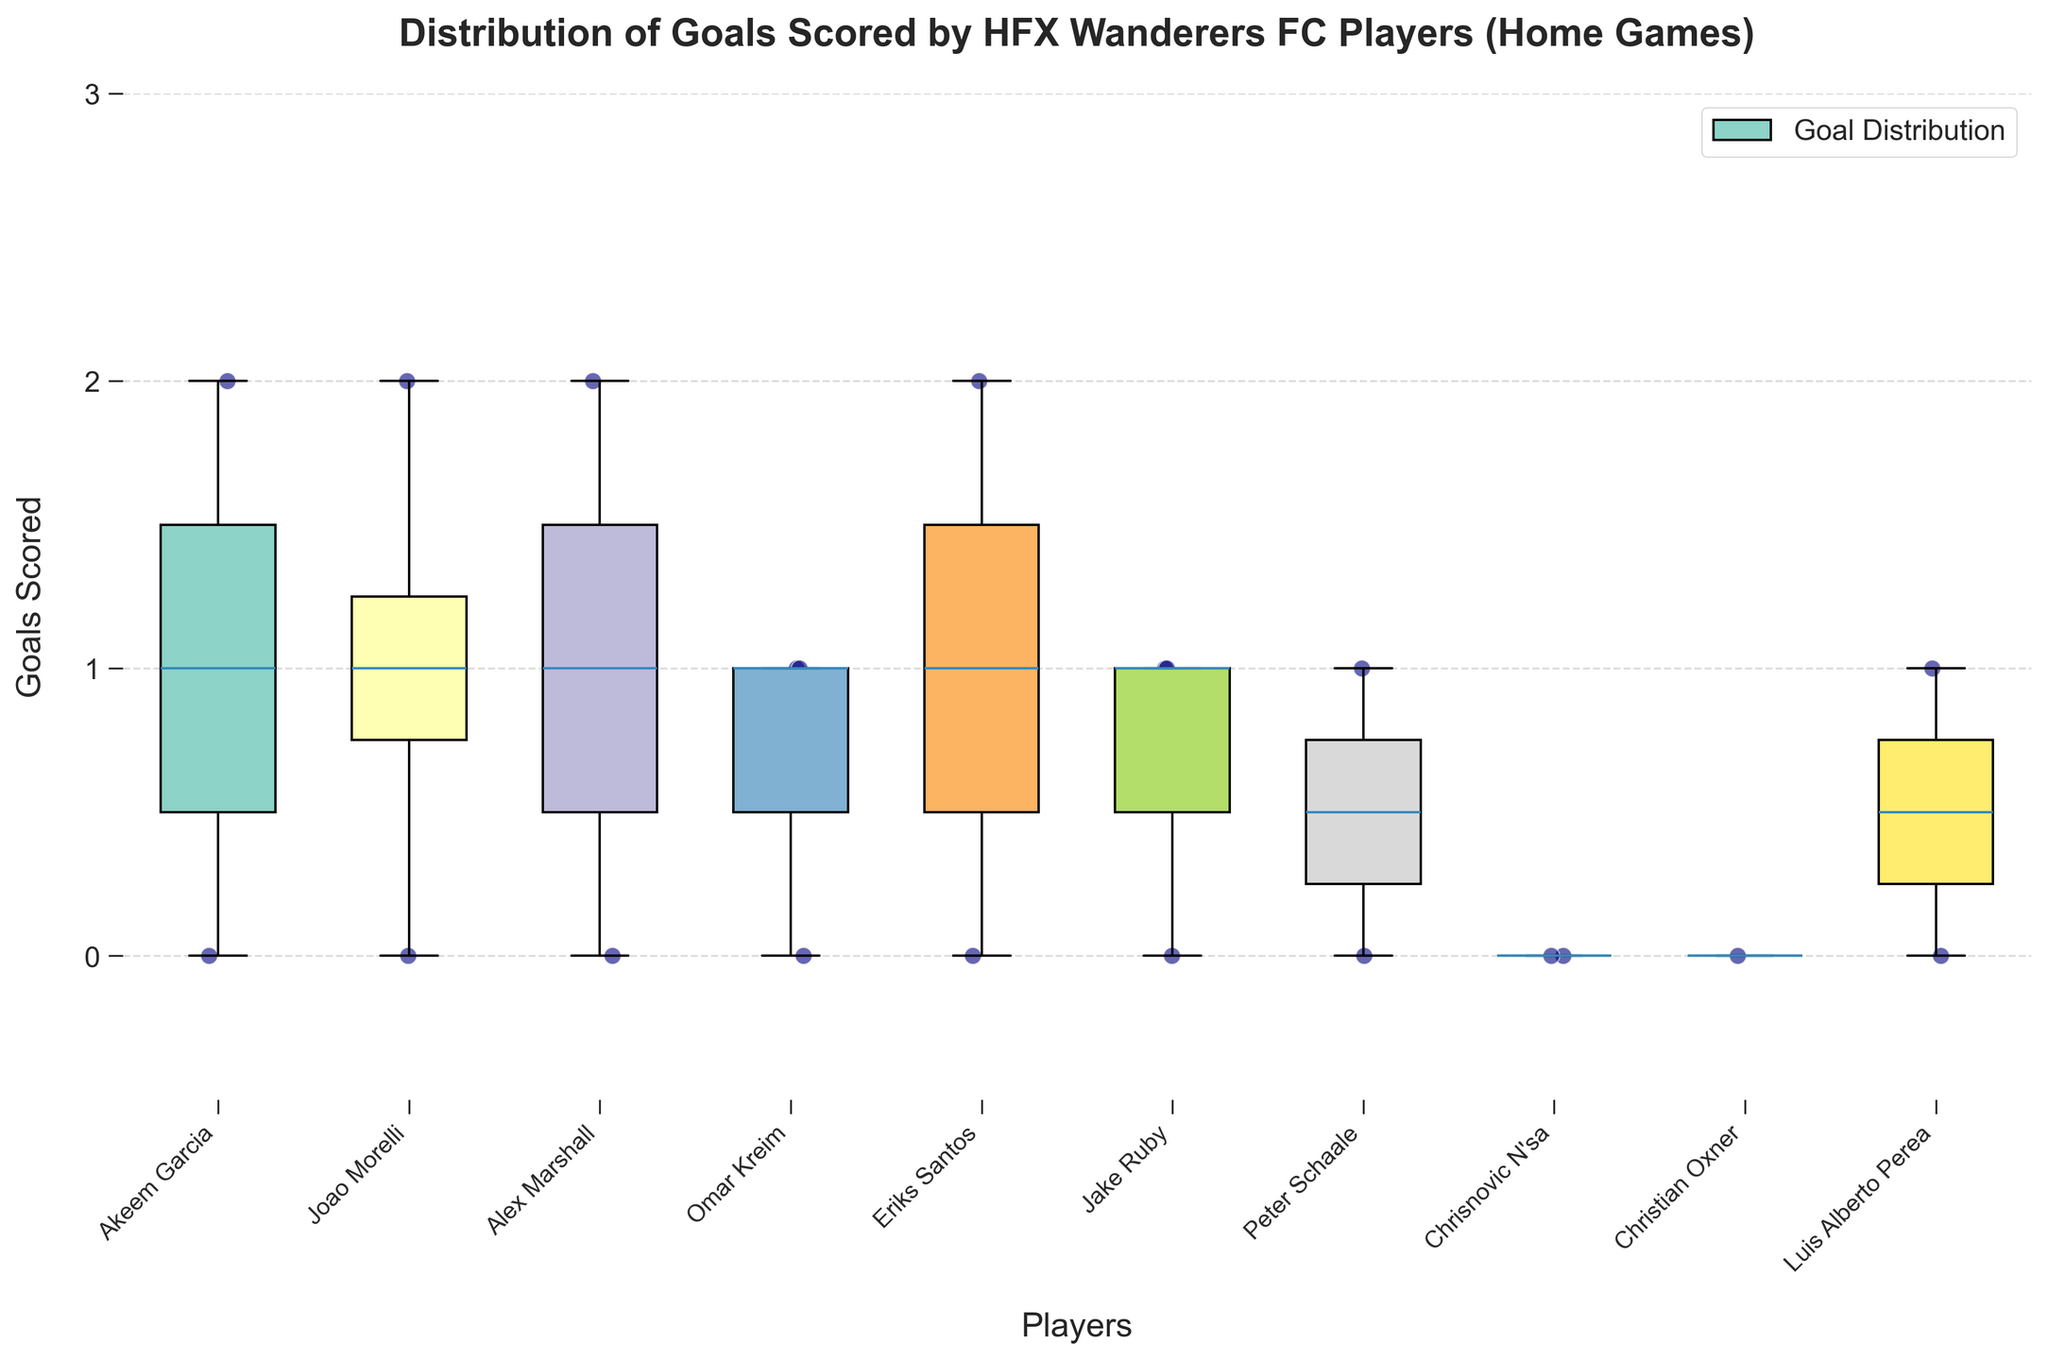What is the title of the plot? The title of the plot is usually displayed at the top of the chart. In this case, it says "Distribution of Goals Scored by HFX Wanderers FC Players (Home Games)."
Answer: Distribution of Goals Scored by HFX Wanderers FC Players (Home Games) How many different players are represented in the plot? The number of different players can be determined by counting the unique labels on the x-axis, each corresponding to a player.
Answer: 11 Which player shows the highest individual goal count in any game? By looking at the highest scatter point for each player, we can see who has the maximum value. Eriks Santos has a scatter point at 2 goals, making him one of the highest scorers in single games.
Answer: Eriks Santos How many goals did Jake Ruby score in the home games? Each scatter point in the box plot represents a game where a player scores. Jake Ruby's scatter points show him scoring 0, 1, and 1 goals in different games. Summing these values gives us the total number of goals.
Answer: 2 Which player has the widest range of goals scored in home games? The range can be identified by the height of the box-and-whisker plots. The wider the spread, the greater the range of goals. Akeem Garcia has individual games with goals of 0, 1, and 2, giving him a range of 0-2.
Answer: Akeem Garcia What's the median number of goals scored by Joao Morelli? The median value in a box plot is represented by the line within the box. Joao Morelli's median line falls at 1 goal.
Answer: 1 How does the goal distribution of Omar Kreim compare to Alex Marshall? By looking at the box plots and scatter points of both players, Omar Kreim consistently scores close to 1 goal (with no extremes), while Alex Marshall scores across 0, 1, and 2 goals with potentially broader distribution.
Answer: Omar Kreim has a more consistent goal-scoring rate; Alex Marshall has a broader range Which player has the most consistent goal-scoring performance? The player with the smallest interquartile range (IQR), indicated by the tightest box, has the most consistent performance. Omar Kreim's box plot is very narrow, indicating a small IQR around 1 goal.
Answer: Omar Kreim What is the highest goal scored by any player in a single home game? The highest scatter point across all players indicates the maximum goals scored in a game. Multiple players, like Eriks Santos and Joao Morelli, have high values reaching 2 goals.
Answer: 2 How many goals did Peter Schaale score during home games? Looking at the scatter points for Peter Schaale can determine his total goals. He has 0 and 1 goals. Adding these gives the total goals.
Answer: 1 